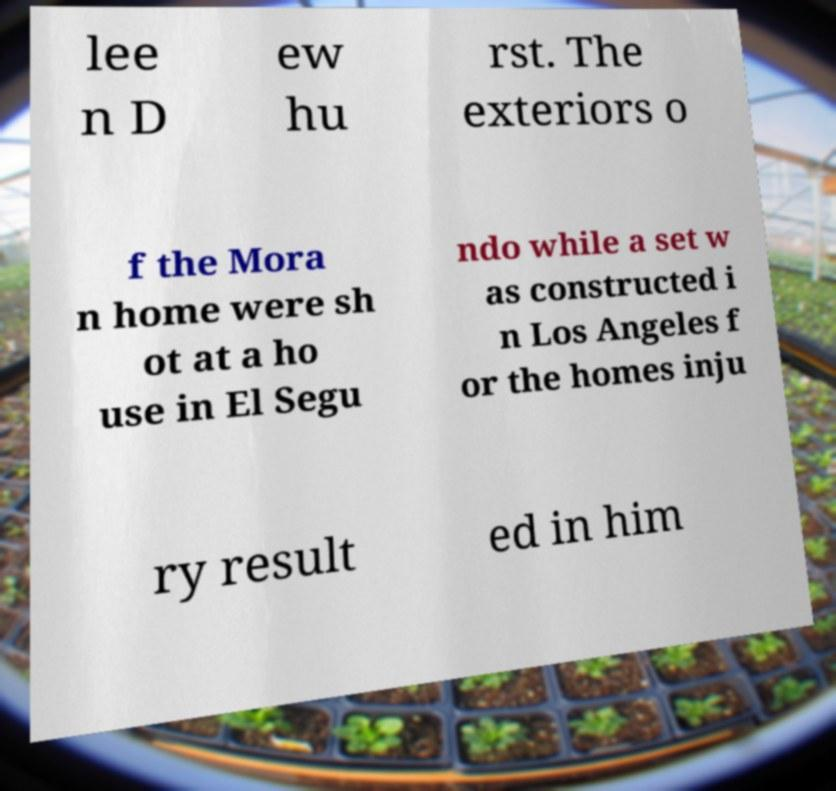Can you read and provide the text displayed in the image?This photo seems to have some interesting text. Can you extract and type it out for me? lee n D ew hu rst. The exteriors o f the Mora n home were sh ot at a ho use in El Segu ndo while a set w as constructed i n Los Angeles f or the homes inju ry result ed in him 